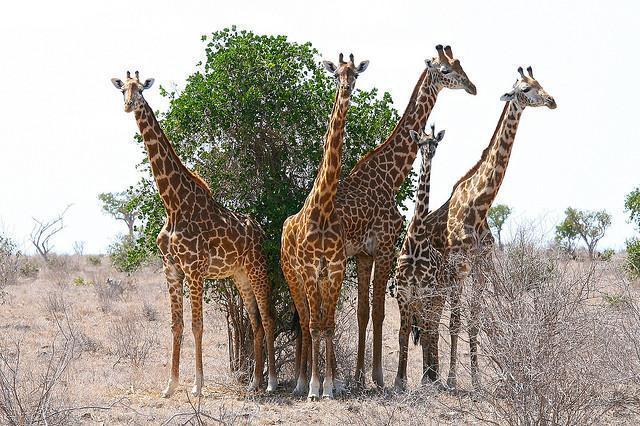How many giraffes are shown?
Give a very brief answer. 5. How many animals are there?
Give a very brief answer. 5. How many giraffes are there?
Give a very brief answer. 5. 